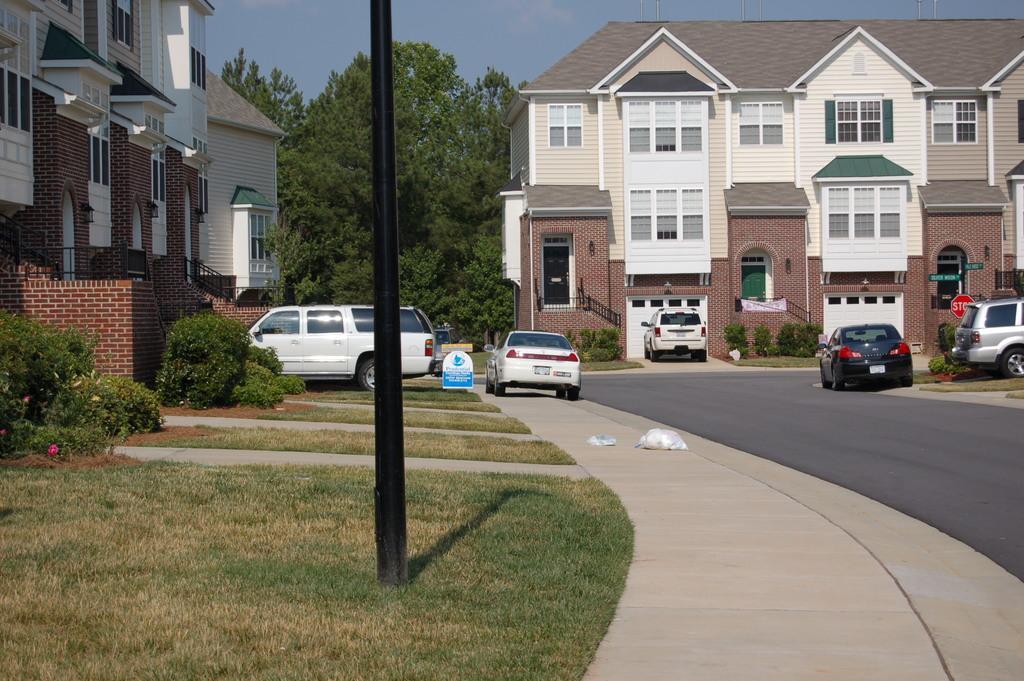How would you summarize this image in a sentence or two? This picture is clicked outside the city. At the bottom, we see the road. In front of the picture, we see a pole. On the left side, we see the plants and a building in white and brown color. In the middle, we see the cars parked on the road. Beside that, we see a board in white and blue color with some text written on it. On the right side, we see the boards in green and red color. In the background, we see the trees and a building in white and brown color. At the top, we see the sky. 